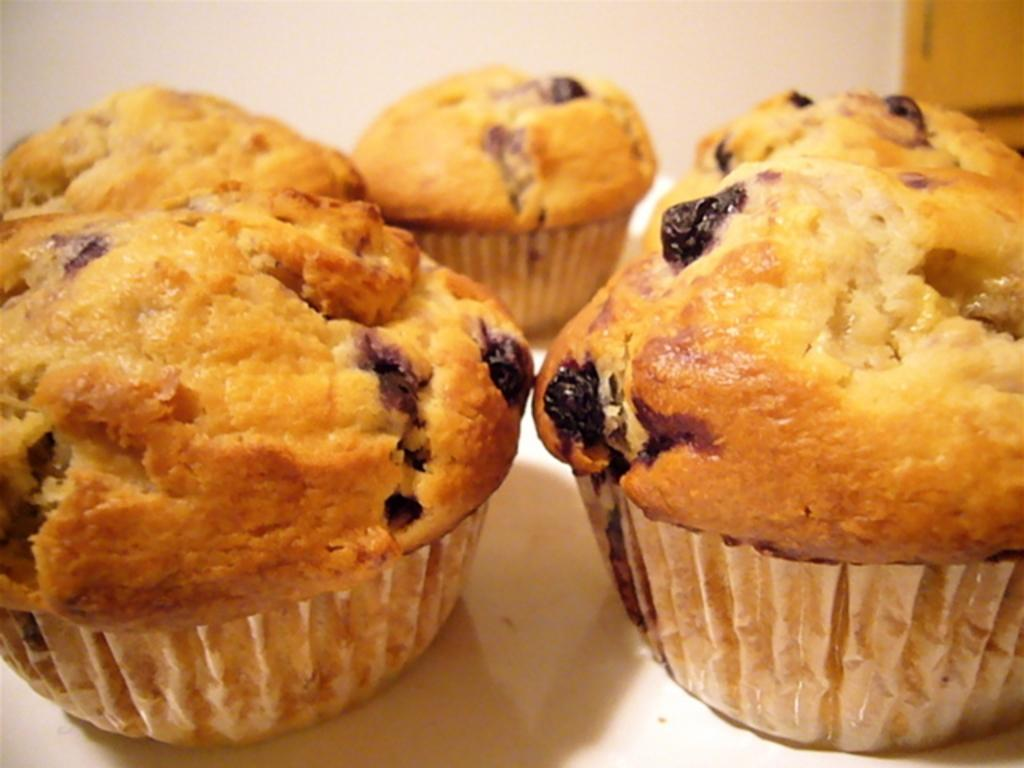What type of food is present in the image? There are cupcakes in the image. Where are the cupcakes located? The cupcakes are on a platform. What can be seen in the background of the image? There is a wall visible in the background of the image. What type of power source is visible in the image? There is no power source visible in the image; it only features cupcakes on a platform and a wall in the background. 